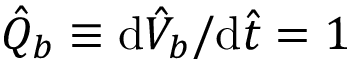Convert formula to latex. <formula><loc_0><loc_0><loc_500><loc_500>\hat { Q } _ { b } \equiv d \hat { V } _ { b } / d \hat { t } = 1</formula> 